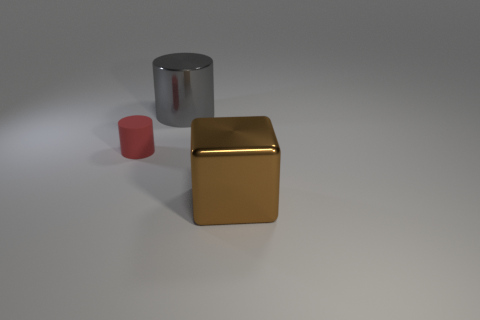What number of objects are either big metal objects behind the brown shiny thing or objects that are behind the brown metal thing?
Give a very brief answer. 2. What is the shape of the object that is both in front of the gray object and to the right of the small red cylinder?
Keep it short and to the point. Cube. There is a large thing on the left side of the big shiny block; what number of big gray metallic things are in front of it?
Make the answer very short. 0. Is there any other thing that has the same material as the gray thing?
Your answer should be compact. Yes. How many objects are cylinders left of the gray object or blue shiny cylinders?
Make the answer very short. 1. What size is the cylinder to the left of the big shiny cylinder?
Keep it short and to the point. Small. What is the material of the big gray thing?
Ensure brevity in your answer.  Metal. What is the shape of the object that is on the right side of the big shiny thing that is behind the tiny red rubber cylinder?
Keep it short and to the point. Cube. How many other objects are the same shape as the tiny red rubber object?
Provide a succinct answer. 1. There is a gray shiny cylinder; are there any matte cylinders behind it?
Provide a short and direct response. No. 